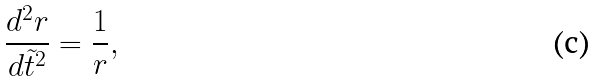Convert formula to latex. <formula><loc_0><loc_0><loc_500><loc_500>\frac { d ^ { 2 } r } { d \tilde { t } ^ { 2 } } = \frac { 1 } { r } ,</formula> 